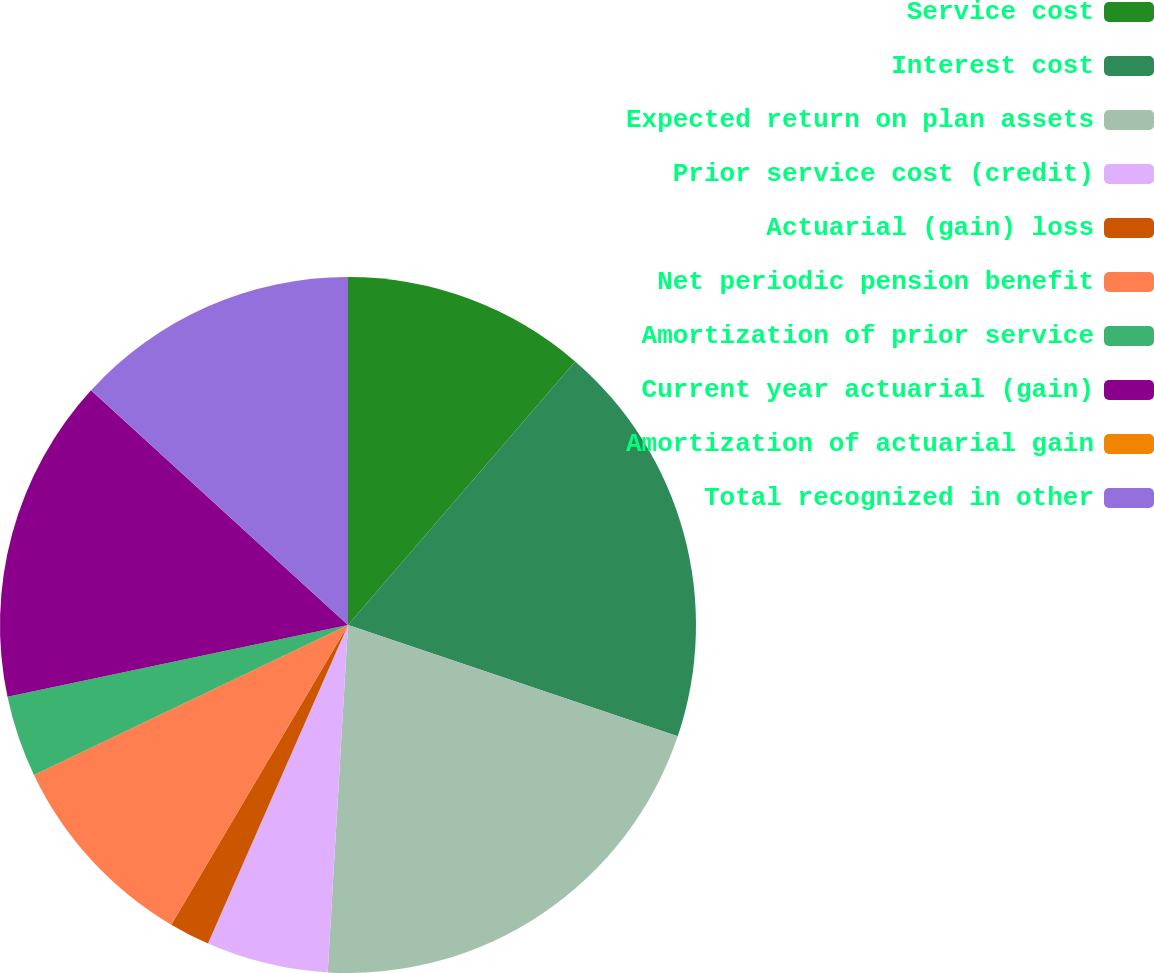<chart> <loc_0><loc_0><loc_500><loc_500><pie_chart><fcel>Service cost<fcel>Interest cost<fcel>Expected return on plan assets<fcel>Prior service cost (credit)<fcel>Actuarial (gain) loss<fcel>Net periodic pension benefit<fcel>Amortization of prior service<fcel>Current year actuarial (gain)<fcel>Amortization of actuarial gain<fcel>Total recognized in other<nl><fcel>11.32%<fcel>18.86%<fcel>20.75%<fcel>5.66%<fcel>1.89%<fcel>9.43%<fcel>3.78%<fcel>15.09%<fcel>0.01%<fcel>13.21%<nl></chart> 